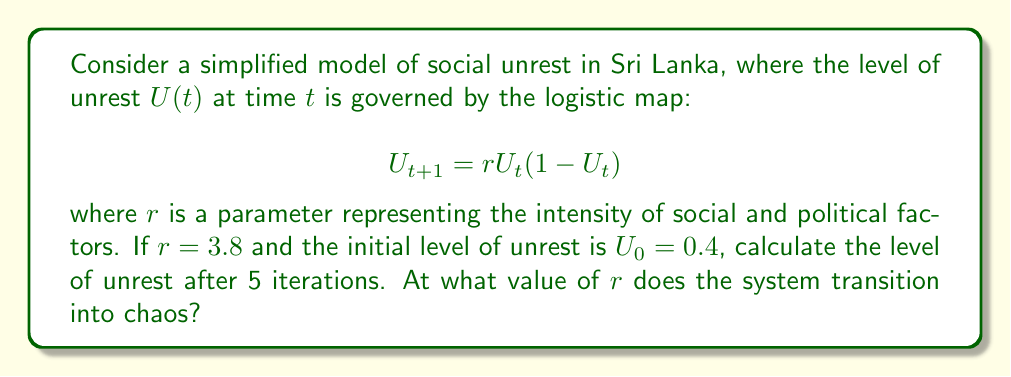Can you solve this math problem? 1) We'll use the logistic map equation to calculate $U_t$ for $t = 1$ to $5$:

   $U_{t+1} = 3.8U_t(1-U_t)$

2) Starting with $U_0 = 0.4$:
   
   $U_1 = 3.8(0.4)(1-0.4) = 0.912$
   
   $U_2 = 3.8(0.912)(1-0.912) = 0.3053$
   
   $U_3 = 3.8(0.3053)(1-0.3053) = 0.8066$
   
   $U_4 = 3.8(0.8066)(1-0.8066) = 0.5942$
   
   $U_5 = 3.8(0.5942)(1-0.5942) = 0.9157$

3) The level of unrest after 5 iterations is approximately 0.9157.

4) The logistic map transitions into chaos at $r ≈ 3.57$. This is known as the onset of chaos or the accumulation point in the period-doubling bifurcation diagram. At this point, the system becomes extremely sensitive to initial conditions, a hallmark of chaos.

5) For $r > 3.57$, the system exhibits chaotic behavior, with occasional "windows" of periodic behavior. The value $r = 3.8$ used in this problem falls within the chaotic regime, which could be interpreted as unpredictable fluctuations in social unrest.
Answer: $U_5 ≈ 0.9157$; Chaos onset at $r ≈ 3.57$ 